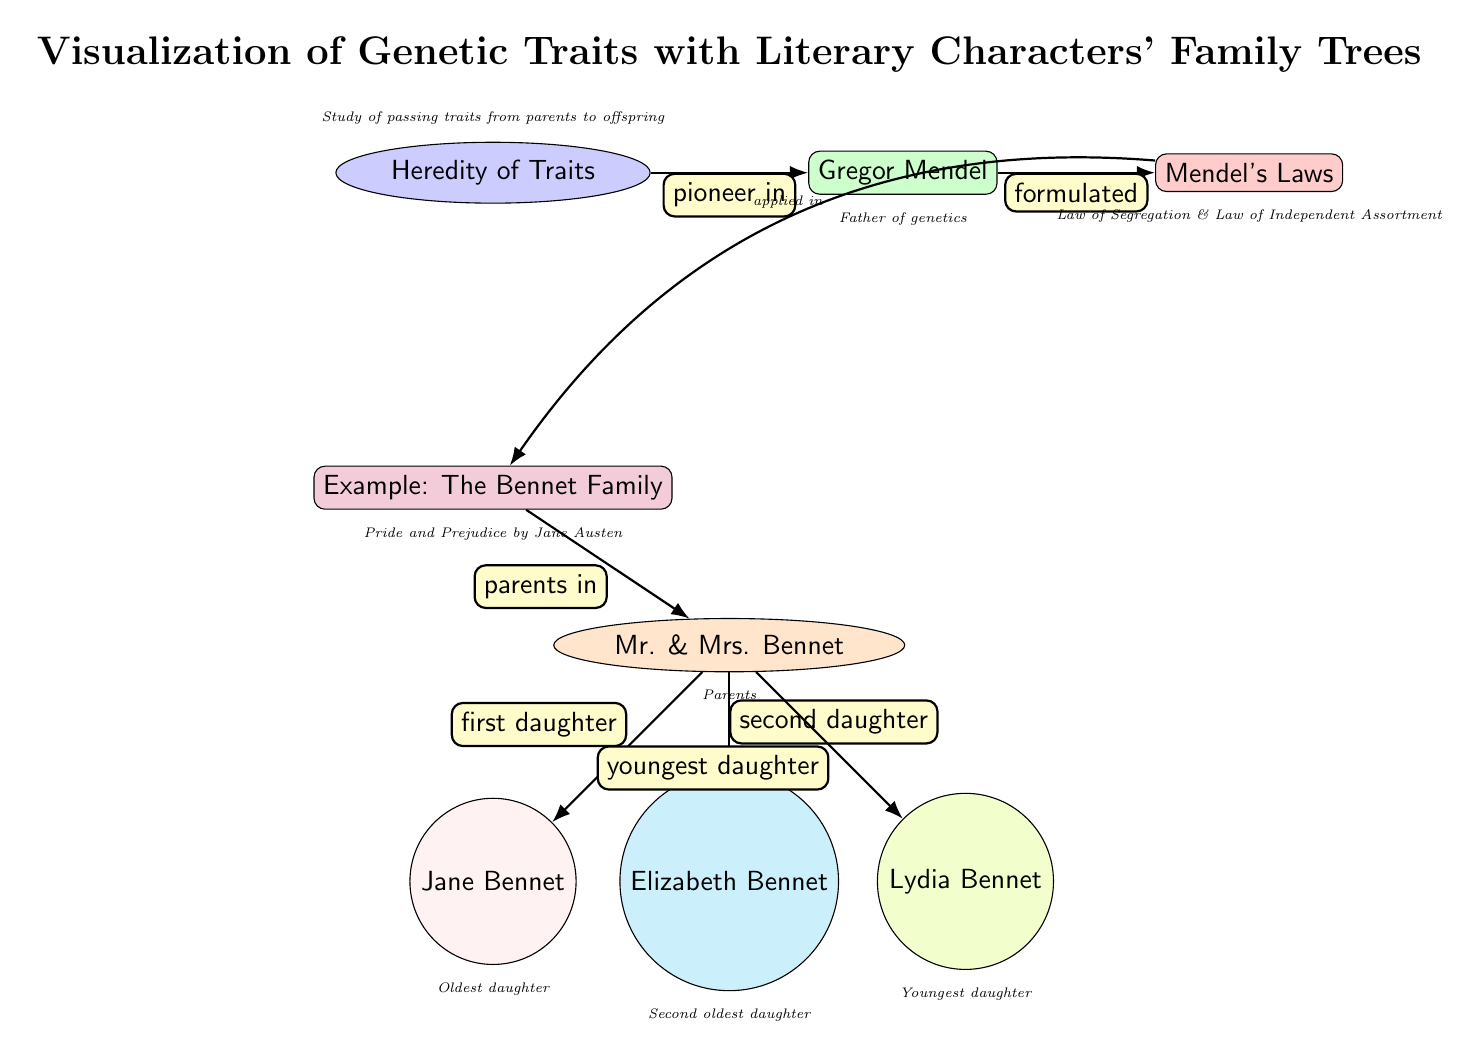What is the main title of the diagram? The title of the diagram is clearly stated at the top: "Visualization of Genetic Traits with Literary Characters' Family Trees." This represents the main subject of the diagram.
Answer: Visualization of Genetic Traits with Literary Characters' Family Trees Who is the pioneer in genetics mentioned in the diagram? The diagram directly identifies Gregor Mendel as the pioneer in genetics, indicated by the arrow leading to his node from "Heredity of Traits."
Answer: Gregor Mendel What relationship do Mr. and Mrs. Bennet have with the Bennet family? Mr. and Mrs. Bennet are labeled as the parents of the three daughters (Jane, Elizabeth, and Lydia), which is indicated by the connection from their node to the "Example: The Bennet Family" node.
Answer: parents How many daughters are shown in the Bennet family? The diagram provides three nodes representing Jane, Elizabeth, and Lydia as daughters of Mr. and Mrs. Bennet, indicating a total of three daughters in the family.
Answer: 3 What do Mendel's laws relate to in this diagram? The diagram demonstrates that Mendel's Laws are applied to the example of the Bennet family, explicitly linking Mendel's Laws with the family tree shown.
Answer: applied in What is the significance of Jane Bennet's position in the diagram? Jane Bennet is labeled as the "Oldest daughter" in the diagram, clearly indicating her position as the first daughter in the familial hierarchy.
Answer: Oldest daughter What literary work is referenced in the diagram? The diagram references "Pride and Prejudice," which is linked to the example of the Bennet family, signaling the source of the family tree being illustrated.
Answer: Pride and Prejudice Which genetic laws are associated with Mendel in the diagram? The diagram mentions two specific laws associated with Mendel: the Law of Segregation and the Law of Independent Assortment, indicated under the node of Mendel's Laws.
Answer: Law of Segregation & Law of Independent Assortment What color is used for the node representing Elizabeth Bennet? The node for Elizabeth Bennet is distinctly colored cyan, which can be identified by looking at the color filling of her node in the diagram.
Answer: cyan 